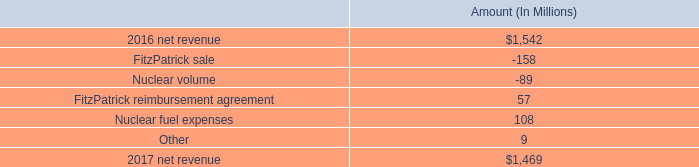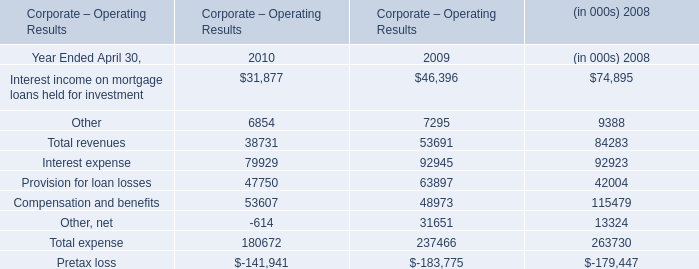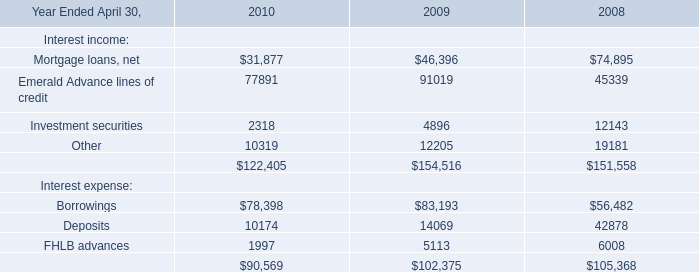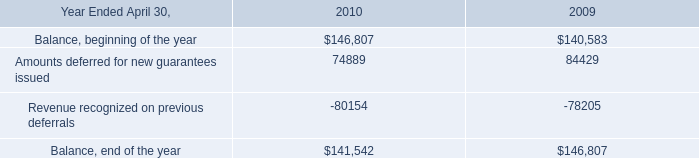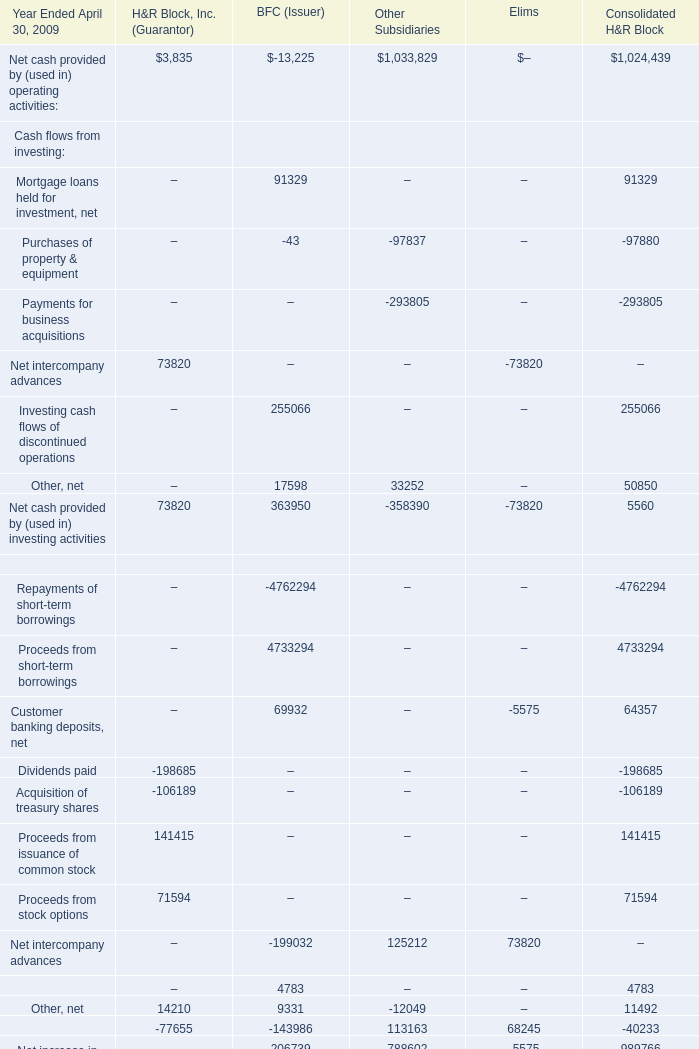What was the average value of the Customer banking deposits, net in the year where Mortgage loans held for investment, net is positive? 
Computations: (((69932 - 5575) + 64357) / 5)
Answer: 25742.8. 